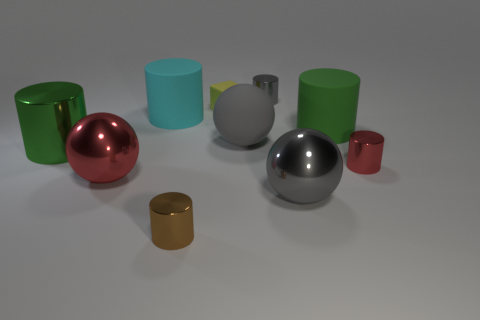Are there any other things that have the same shape as the cyan thing?
Ensure brevity in your answer.  Yes. What is the green object left of the big red metallic thing made of?
Offer a very short reply. Metal. There is a red metallic object that is the same shape as the large gray metal thing; what is its size?
Give a very brief answer. Large. What number of brown cylinders are the same material as the large red ball?
Your answer should be compact. 1. What number of things are the same color as the big matte sphere?
Your answer should be compact. 2. How many things are tiny metallic cylinders in front of the gray matte ball or shiny cylinders on the left side of the cyan matte object?
Your answer should be compact. 3. Is the number of small rubber things on the left side of the rubber cube less than the number of big gray cubes?
Give a very brief answer. No. Are there any yellow rubber objects that have the same size as the gray metal cylinder?
Ensure brevity in your answer.  Yes. What color is the rubber sphere?
Give a very brief answer. Gray. Is the gray cylinder the same size as the yellow rubber block?
Provide a short and direct response. Yes. 